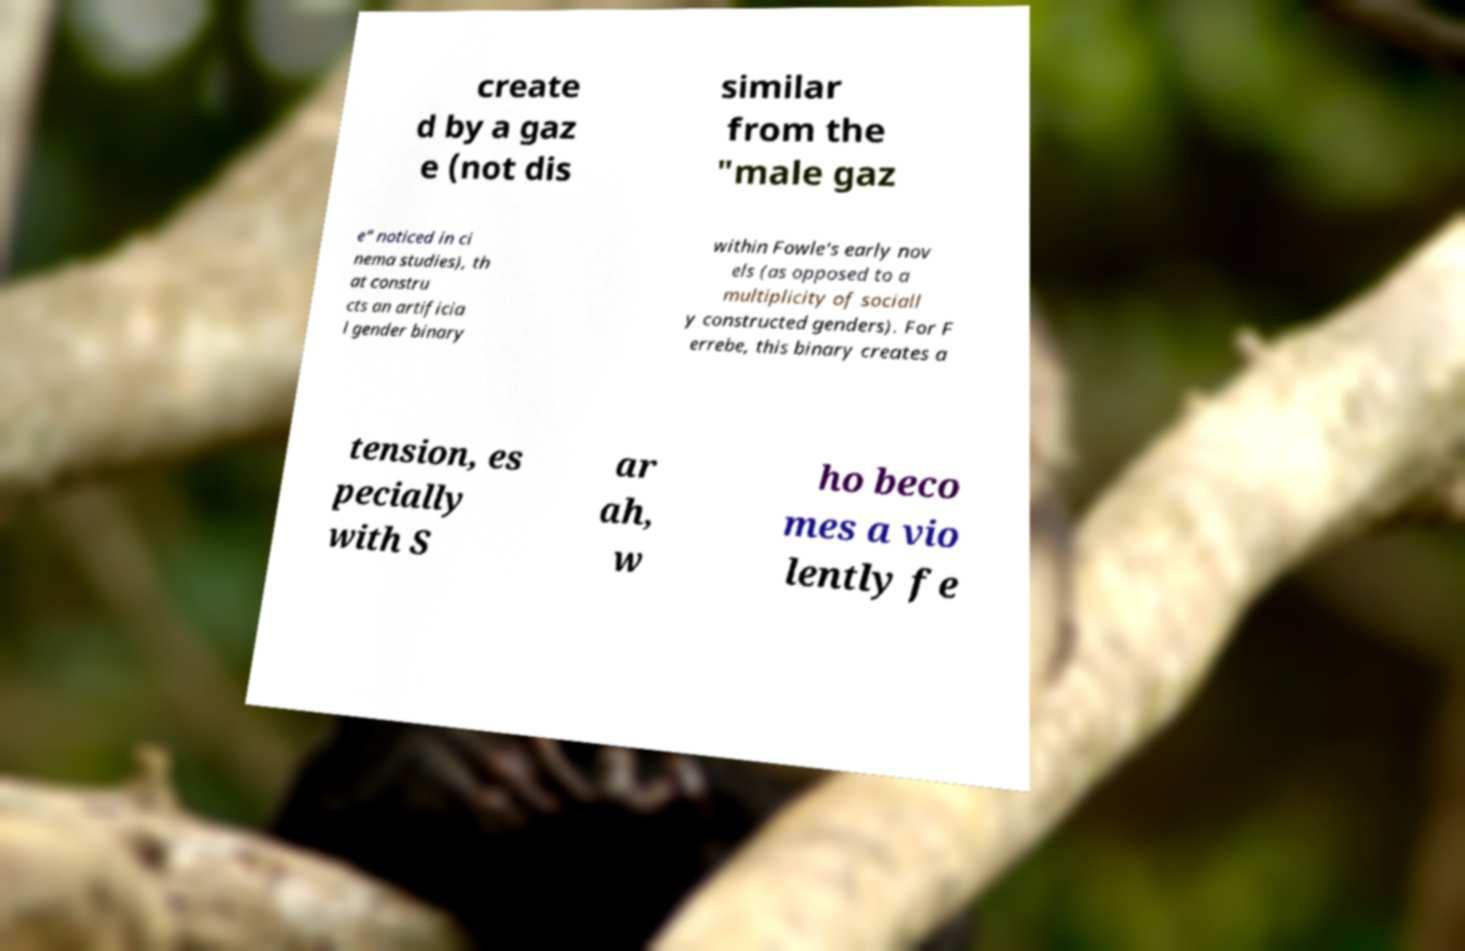Could you assist in decoding the text presented in this image and type it out clearly? create d by a gaz e (not dis similar from the "male gaz e" noticed in ci nema studies), th at constru cts an artificia l gender binary within Fowle's early nov els (as opposed to a multiplicity of sociall y constructed genders). For F errebe, this binary creates a tension, es pecially with S ar ah, w ho beco mes a vio lently fe 